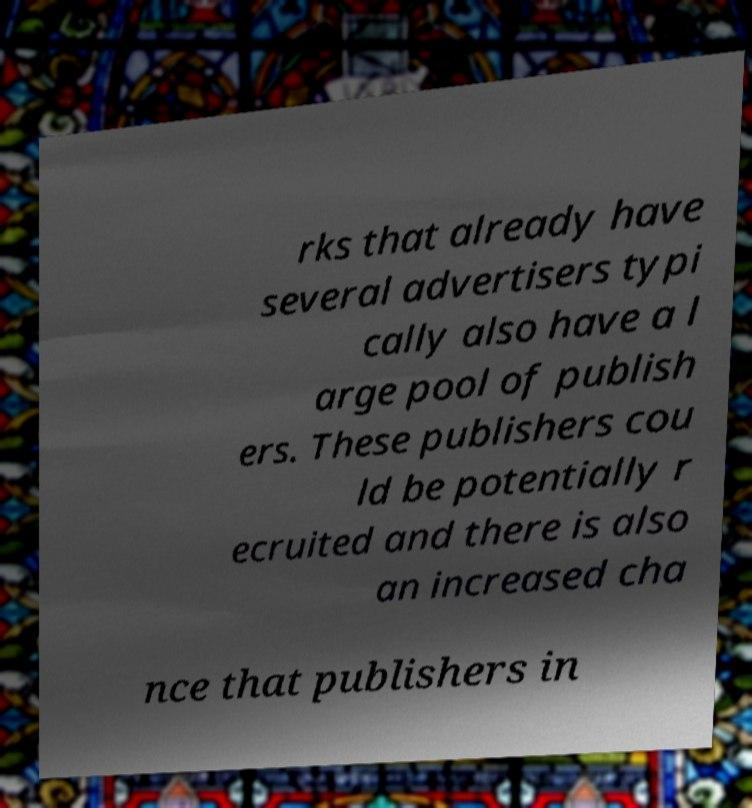Please read and relay the text visible in this image. What does it say? rks that already have several advertisers typi cally also have a l arge pool of publish ers. These publishers cou ld be potentially r ecruited and there is also an increased cha nce that publishers in 